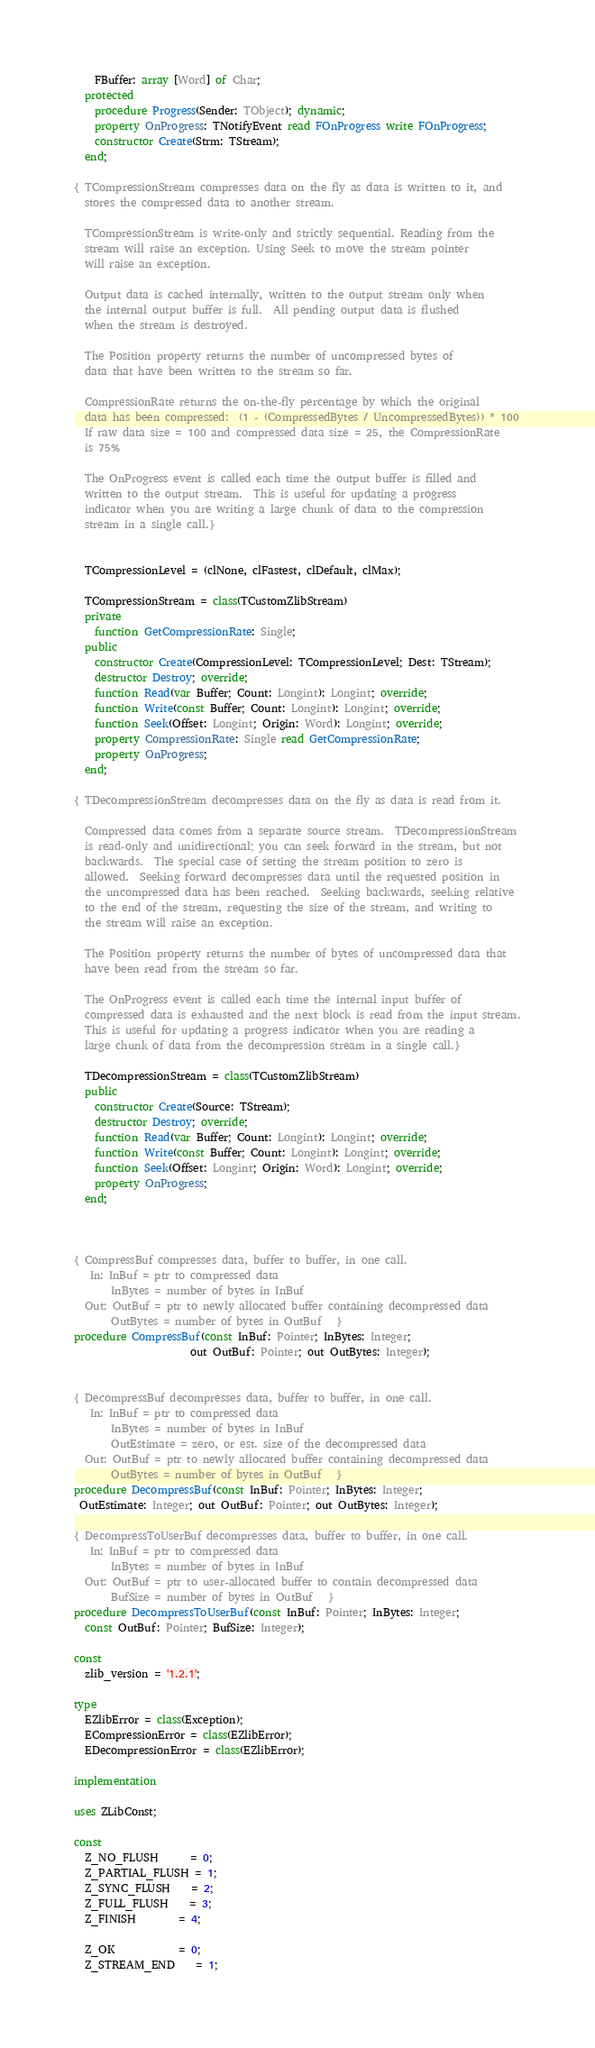<code> <loc_0><loc_0><loc_500><loc_500><_Pascal_>    FBuffer: array [Word] of Char;
  protected
    procedure Progress(Sender: TObject); dynamic;
    property OnProgress: TNotifyEvent read FOnProgress write FOnProgress;
    constructor Create(Strm: TStream);
  end;

{ TCompressionStream compresses data on the fly as data is written to it, and
  stores the compressed data to another stream.

  TCompressionStream is write-only and strictly sequential. Reading from the
  stream will raise an exception. Using Seek to move the stream pointer
  will raise an exception.

  Output data is cached internally, written to the output stream only when
  the internal output buffer is full.  All pending output data is flushed
  when the stream is destroyed.

  The Position property returns the number of uncompressed bytes of
  data that have been written to the stream so far.

  CompressionRate returns the on-the-fly percentage by which the original
  data has been compressed:  (1 - (CompressedBytes / UncompressedBytes)) * 100
  If raw data size = 100 and compressed data size = 25, the CompressionRate
  is 75%

  The OnProgress event is called each time the output buffer is filled and
  written to the output stream.  This is useful for updating a progress
  indicator when you are writing a large chunk of data to the compression
  stream in a single call.}


  TCompressionLevel = (clNone, clFastest, clDefault, clMax);

  TCompressionStream = class(TCustomZlibStream)
  private
    function GetCompressionRate: Single;
  public
    constructor Create(CompressionLevel: TCompressionLevel; Dest: TStream);
    destructor Destroy; override;
    function Read(var Buffer; Count: Longint): Longint; override;
    function Write(const Buffer; Count: Longint): Longint; override;
    function Seek(Offset: Longint; Origin: Word): Longint; override;
    property CompressionRate: Single read GetCompressionRate;
    property OnProgress;
  end;

{ TDecompressionStream decompresses data on the fly as data is read from it.

  Compressed data comes from a separate source stream.  TDecompressionStream
  is read-only and unidirectional; you can seek forward in the stream, but not
  backwards.  The special case of setting the stream position to zero is
  allowed.  Seeking forward decompresses data until the requested position in
  the uncompressed data has been reached.  Seeking backwards, seeking relative
  to the end of the stream, requesting the size of the stream, and writing to
  the stream will raise an exception.

  The Position property returns the number of bytes of uncompressed data that
  have been read from the stream so far.

  The OnProgress event is called each time the internal input buffer of
  compressed data is exhausted and the next block is read from the input stream.
  This is useful for updating a progress indicator when you are reading a
  large chunk of data from the decompression stream in a single call.}

  TDecompressionStream = class(TCustomZlibStream)
  public
    constructor Create(Source: TStream);
    destructor Destroy; override;
    function Read(var Buffer; Count: Longint): Longint; override;
    function Write(const Buffer; Count: Longint): Longint; override;
    function Seek(Offset: Longint; Origin: Word): Longint; override;
    property OnProgress;
  end;



{ CompressBuf compresses data, buffer to buffer, in one call.
   In: InBuf = ptr to compressed data
       InBytes = number of bytes in InBuf
  Out: OutBuf = ptr to newly allocated buffer containing decompressed data
       OutBytes = number of bytes in OutBuf   }
procedure CompressBuf(const InBuf: Pointer; InBytes: Integer;
                      out OutBuf: Pointer; out OutBytes: Integer);


{ DecompressBuf decompresses data, buffer to buffer, in one call.
   In: InBuf = ptr to compressed data
       InBytes = number of bytes in InBuf
       OutEstimate = zero, or est. size of the decompressed data
  Out: OutBuf = ptr to newly allocated buffer containing decompressed data
       OutBytes = number of bytes in OutBuf   }
procedure DecompressBuf(const InBuf: Pointer; InBytes: Integer;
 OutEstimate: Integer; out OutBuf: Pointer; out OutBytes: Integer);

{ DecompressToUserBuf decompresses data, buffer to buffer, in one call.
   In: InBuf = ptr to compressed data
       InBytes = number of bytes in InBuf
  Out: OutBuf = ptr to user-allocated buffer to contain decompressed data
       BufSize = number of bytes in OutBuf   }
procedure DecompressToUserBuf(const InBuf: Pointer; InBytes: Integer;
  const OutBuf: Pointer; BufSize: Integer);

const
  zlib_version = '1.2.1';

type
  EZlibError = class(Exception);
  ECompressionError = class(EZlibError);
  EDecompressionError = class(EZlibError);

implementation

uses ZLibConst;

const
  Z_NO_FLUSH      = 0;
  Z_PARTIAL_FLUSH = 1;
  Z_SYNC_FLUSH    = 2;
  Z_FULL_FLUSH    = 3;
  Z_FINISH        = 4;

  Z_OK            = 0;
  Z_STREAM_END    = 1;</code> 